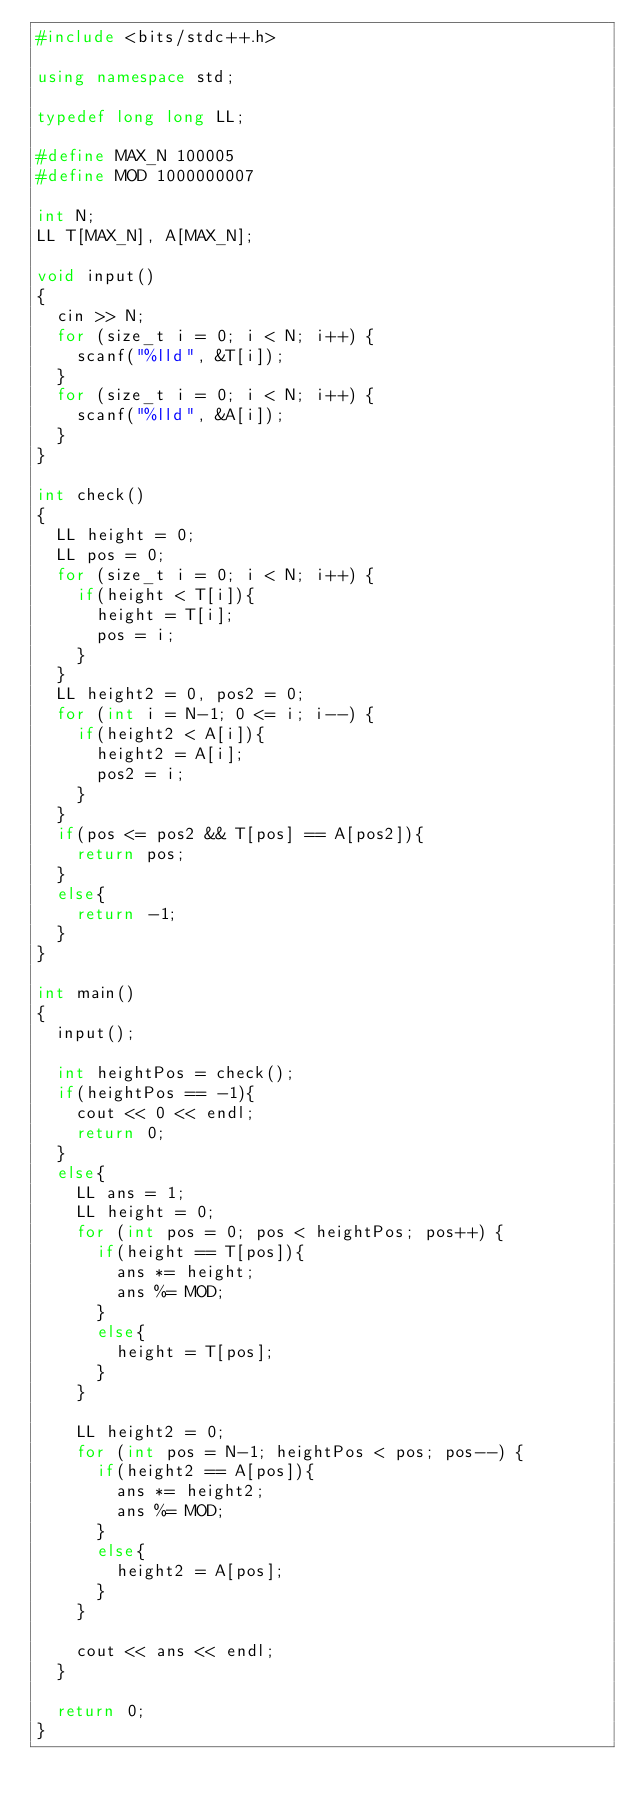Convert code to text. <code><loc_0><loc_0><loc_500><loc_500><_C++_>#include <bits/stdc++.h>

using namespace std;

typedef long long LL;

#define MAX_N 100005
#define MOD 1000000007

int N;
LL T[MAX_N], A[MAX_N];

void input()
{
  cin >> N;
  for (size_t i = 0; i < N; i++) {
    scanf("%lld", &T[i]);
  }
  for (size_t i = 0; i < N; i++) {
    scanf("%lld", &A[i]);
  }
}

int check()
{
  LL height = 0;
  LL pos = 0;
  for (size_t i = 0; i < N; i++) {
    if(height < T[i]){
      height = T[i];
      pos = i;
    }
  }
  LL height2 = 0, pos2 = 0;
  for (int i = N-1; 0 <= i; i--) {
    if(height2 < A[i]){
      height2 = A[i];
      pos2 = i;
    }
  }
  if(pos <= pos2 && T[pos] == A[pos2]){
    return pos;
  }
  else{
    return -1;
  }
}

int main()
{
  input();

  int heightPos = check();
  if(heightPos == -1){
    cout << 0 << endl;
    return 0;
  }
  else{
    LL ans = 1;
    LL height = 0;
    for (int pos = 0; pos < heightPos; pos++) {
      if(height == T[pos]){
        ans *= height;
        ans %= MOD;
      }
      else{
        height = T[pos];
      }
    }

    LL height2 = 0;
    for (int pos = N-1; heightPos < pos; pos--) {
      if(height2 == A[pos]){
        ans *= height2;
        ans %= MOD;
      }
      else{
        height2 = A[pos];
      }
    }

    cout << ans << endl;
  }

  return 0;
}
</code> 